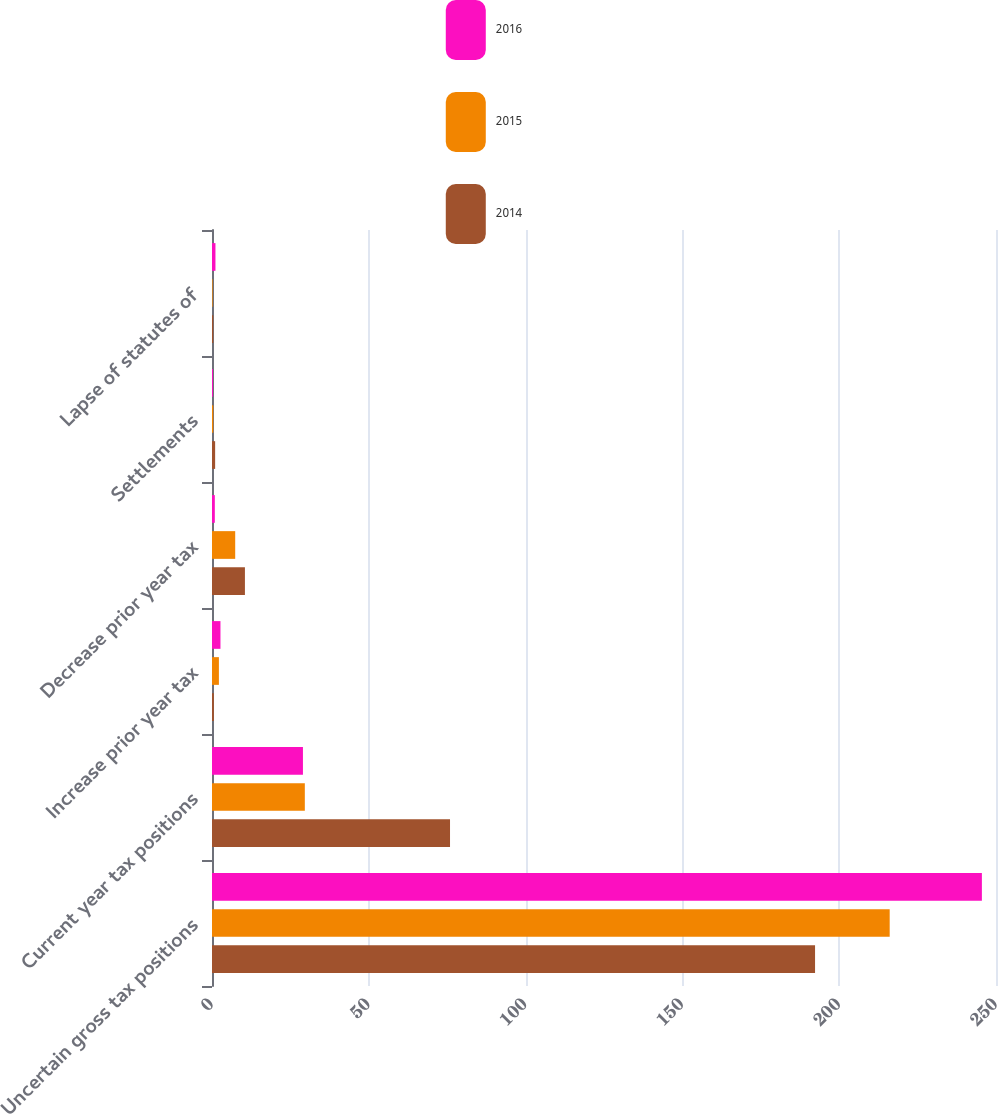Convert chart to OTSL. <chart><loc_0><loc_0><loc_500><loc_500><stacked_bar_chart><ecel><fcel>Uncertain gross tax positions<fcel>Current year tax positions<fcel>Increase prior year tax<fcel>Decrease prior year tax<fcel>Settlements<fcel>Lapse of statutes of<nl><fcel>2016<fcel>245.5<fcel>29<fcel>2.7<fcel>0.9<fcel>0.3<fcel>1.1<nl><fcel>2015<fcel>216.1<fcel>29.6<fcel>2.2<fcel>7.4<fcel>0.4<fcel>0.2<nl><fcel>2014<fcel>192.3<fcel>75.9<fcel>0.6<fcel>10.5<fcel>1<fcel>0.4<nl></chart> 